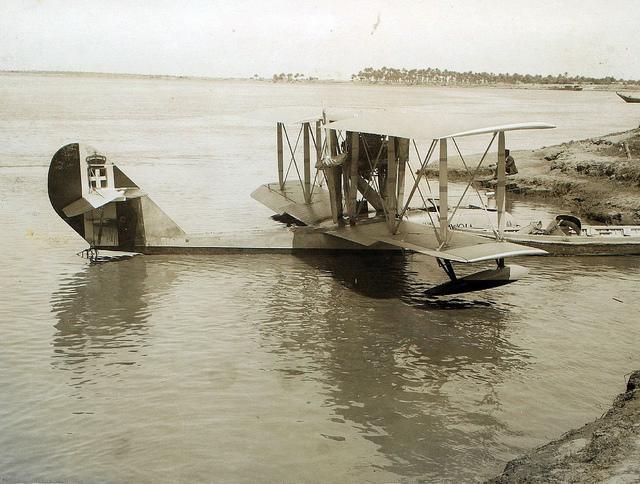How many headlights does this truck have?
Give a very brief answer. 0. 